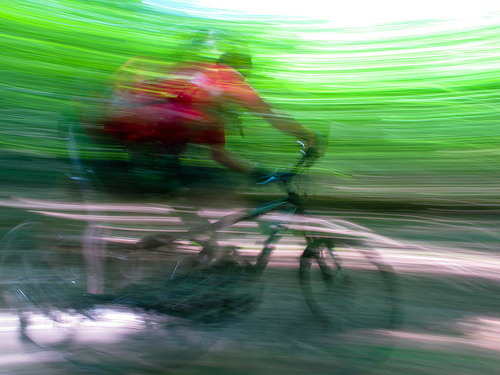<image>
Can you confirm if the human is above the bike? Yes. The human is positioned above the bike in the vertical space, higher up in the scene. 